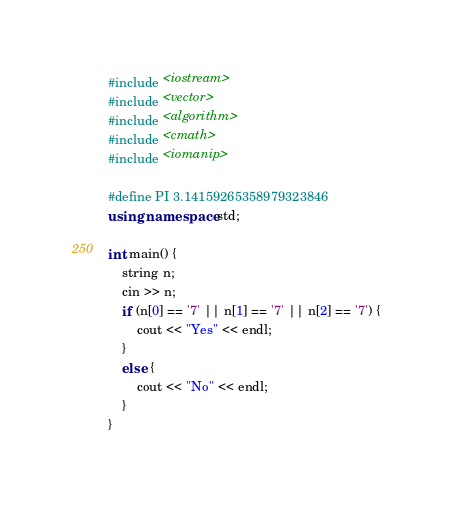Convert code to text. <code><loc_0><loc_0><loc_500><loc_500><_C++_>#include <iostream>
#include <vector>
#include <algorithm>
#include <cmath>
#include <iomanip>

#define PI 3.14159265358979323846
using namespace std;

int main() {
    string n;
    cin >> n;
    if (n[0] == '7' || n[1] == '7' || n[2] == '7') {
        cout << "Yes" << endl;
    }
    else {
        cout << "No" << endl;
    }
}</code> 